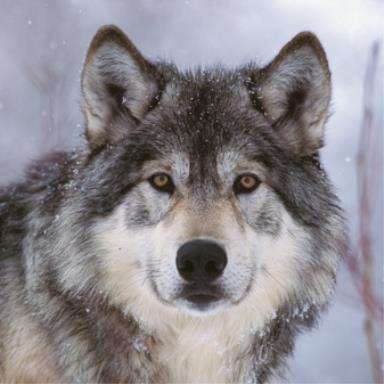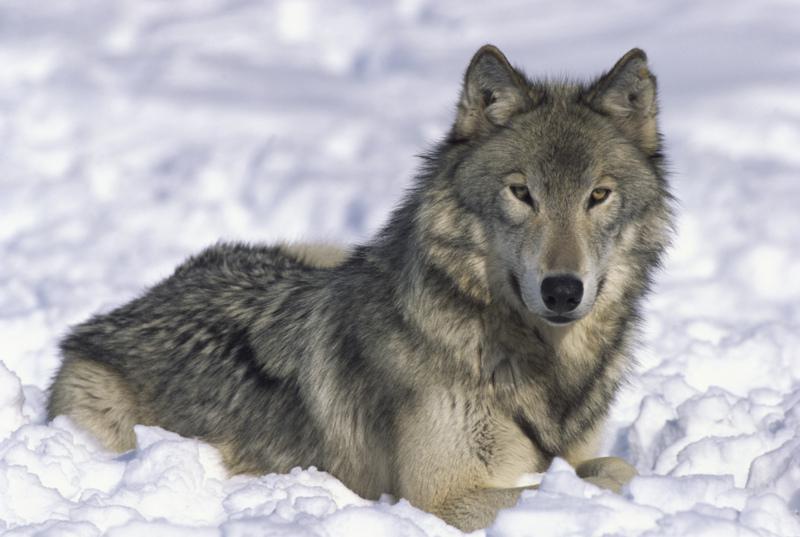The first image is the image on the left, the second image is the image on the right. Analyze the images presented: Is the assertion "There are exactly two wolves in total." valid? Answer yes or no. Yes. The first image is the image on the left, the second image is the image on the right. Given the left and right images, does the statement "The left image contains at least two wolves." hold true? Answer yes or no. No. 